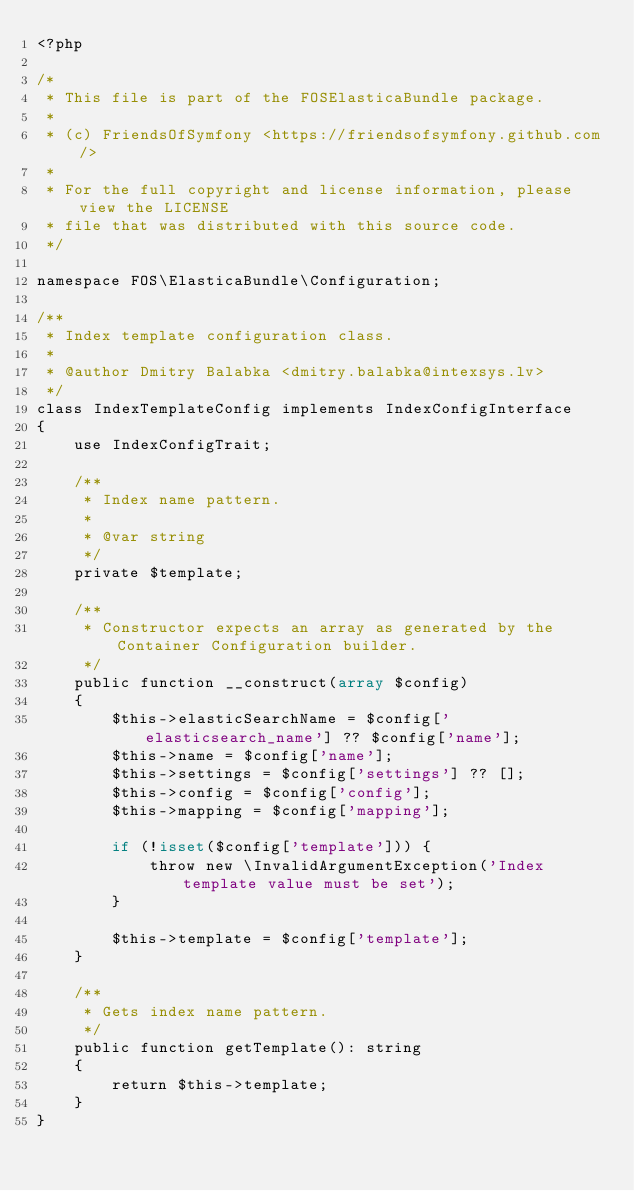<code> <loc_0><loc_0><loc_500><loc_500><_PHP_><?php

/*
 * This file is part of the FOSElasticaBundle package.
 *
 * (c) FriendsOfSymfony <https://friendsofsymfony.github.com/>
 *
 * For the full copyright and license information, please view the LICENSE
 * file that was distributed with this source code.
 */

namespace FOS\ElasticaBundle\Configuration;

/**
 * Index template configuration class.
 *
 * @author Dmitry Balabka <dmitry.balabka@intexsys.lv>
 */
class IndexTemplateConfig implements IndexConfigInterface
{
    use IndexConfigTrait;

    /**
     * Index name pattern.
     *
     * @var string
     */
    private $template;

    /**
     * Constructor expects an array as generated by the Container Configuration builder.
     */
    public function __construct(array $config)
    {
        $this->elasticSearchName = $config['elasticsearch_name'] ?? $config['name'];
        $this->name = $config['name'];
        $this->settings = $config['settings'] ?? [];
        $this->config = $config['config'];
        $this->mapping = $config['mapping'];

        if (!isset($config['template'])) {
            throw new \InvalidArgumentException('Index template value must be set');
        }

        $this->template = $config['template'];
    }

    /**
     * Gets index name pattern.
     */
    public function getTemplate(): string
    {
        return $this->template;
    }
}
</code> 